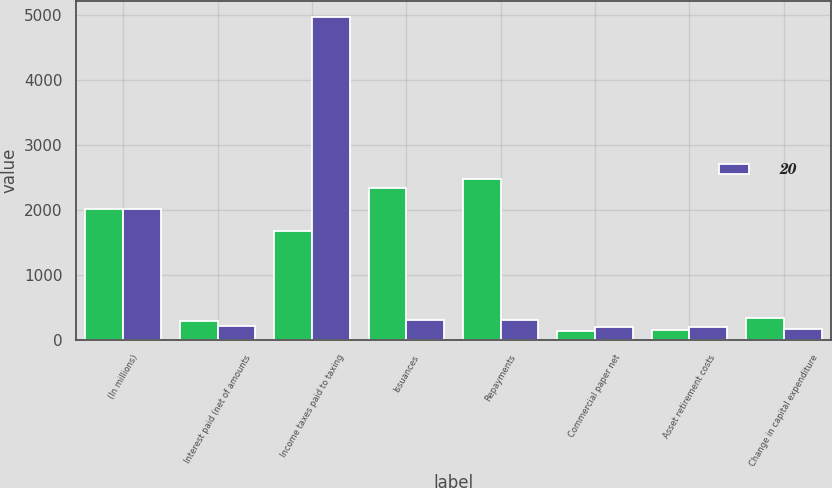<chart> <loc_0><loc_0><loc_500><loc_500><stacked_bar_chart><ecel><fcel>(In millions)<fcel>Interest paid (net of amounts<fcel>Income taxes paid to taxing<fcel>Issuances<fcel>Repayments<fcel>Commercial paper net<fcel>Asset retirement costs<fcel>Change in capital expenditure<nl><fcel>nan<fcel>2014<fcel>289<fcel>1679<fcel>2345<fcel>2480<fcel>135<fcel>151<fcel>335<nl><fcel>20<fcel>2012<fcel>225<fcel>4974<fcel>312<fcel>312<fcel>200<fcel>199<fcel>165<nl></chart> 